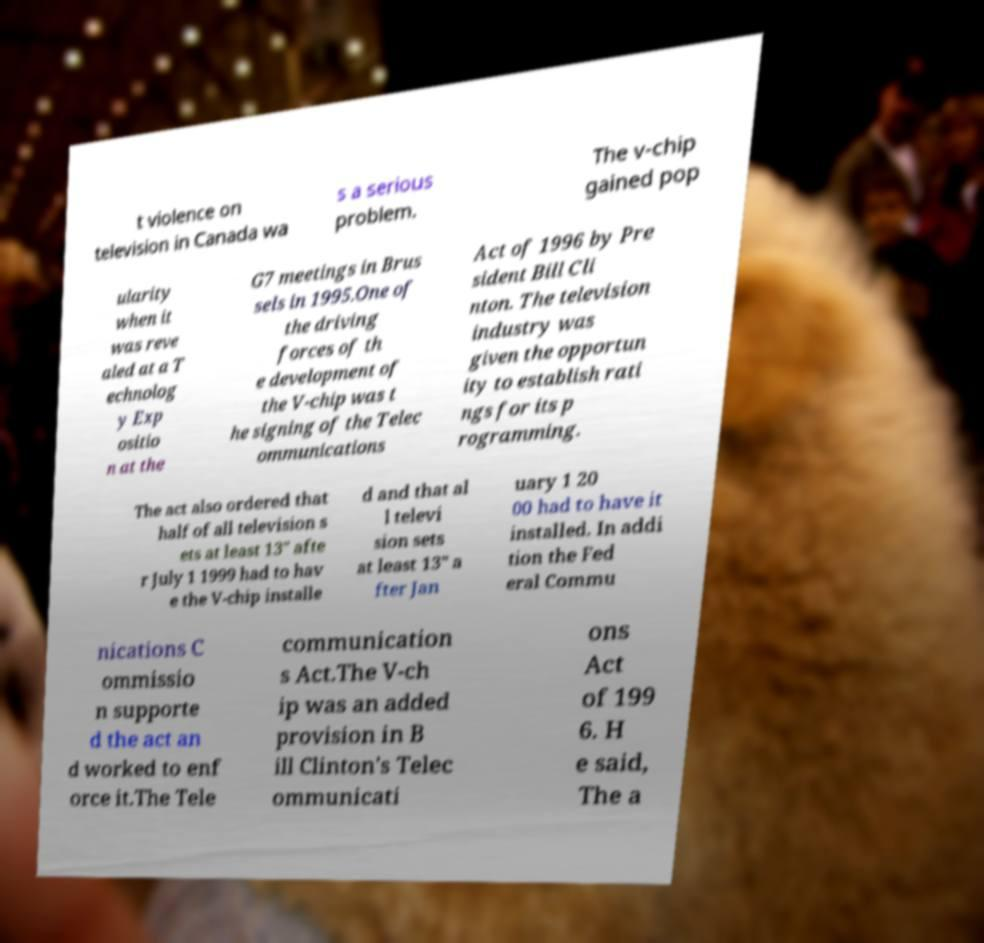I need the written content from this picture converted into text. Can you do that? t violence on television in Canada wa s a serious problem. The v-chip gained pop ularity when it was reve aled at a T echnolog y Exp ositio n at the G7 meetings in Brus sels in 1995.One of the driving forces of th e development of the V-chip was t he signing of the Telec ommunications Act of 1996 by Pre sident Bill Cli nton. The television industry was given the opportun ity to establish rati ngs for its p rogramming. The act also ordered that half of all television s ets at least 13″ afte r July 1 1999 had to hav e the V-chip installe d and that al l televi sion sets at least 13″ a fter Jan uary 1 20 00 had to have it installed. In addi tion the Fed eral Commu nications C ommissio n supporte d the act an d worked to enf orce it.The Tele communication s Act.The V-ch ip was an added provision in B ill Clinton's Telec ommunicati ons Act of 199 6. H e said, The a 